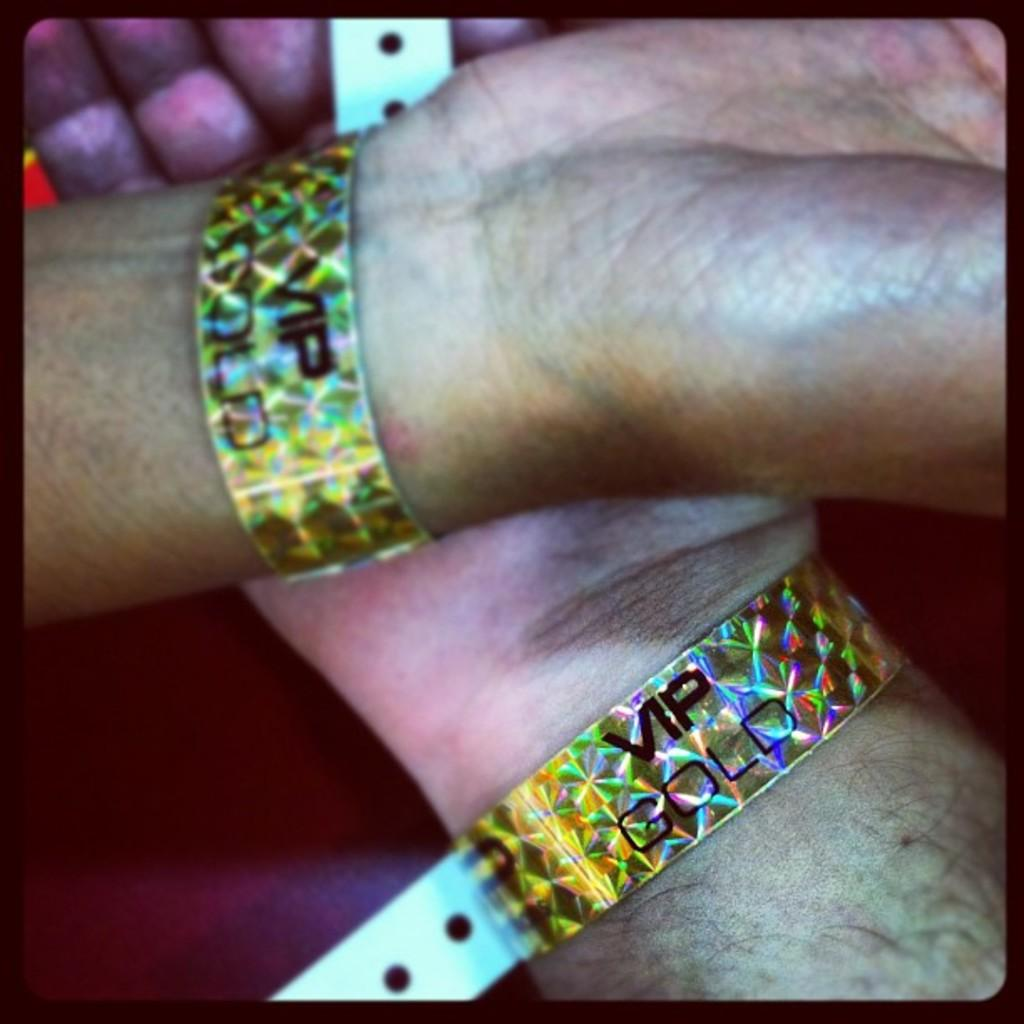What body parts are visible in the image? There are hands visible in the image. What is the person wearing on their wrists? The person is wearing wristbands. What is written on the wristbands? The wristbands have "VIP GOLD" written on them. What color is the crayon being used by the person in the image? There is no crayon present in the image. 